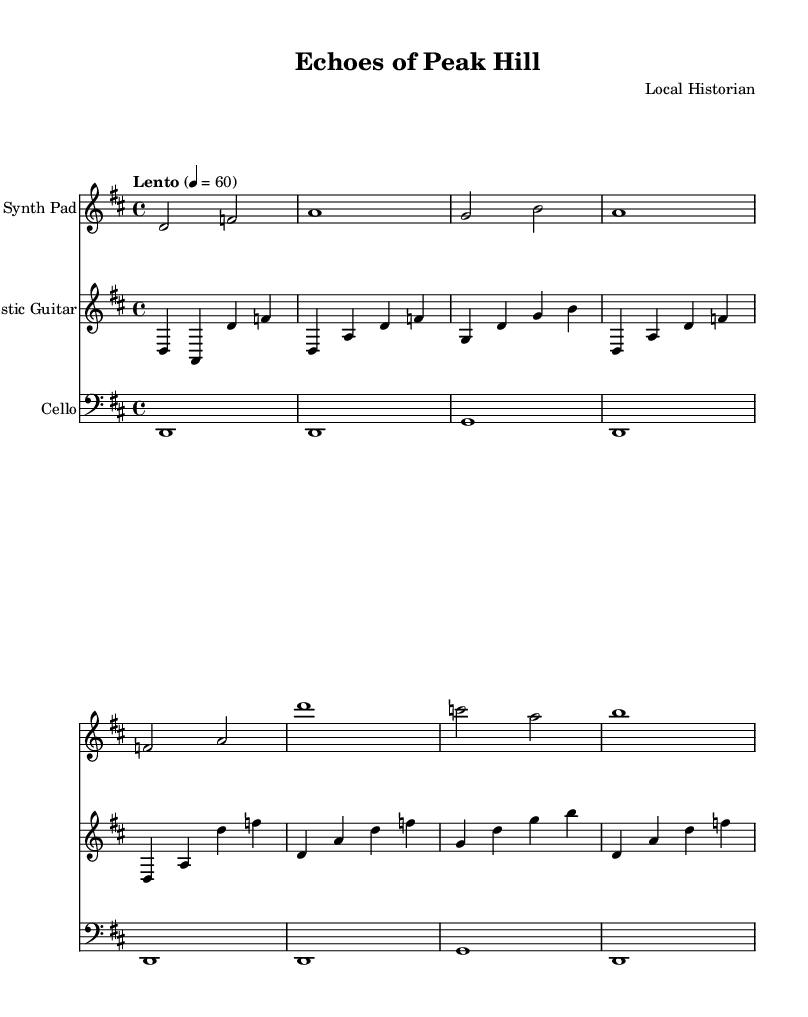What is the key signature of this music? The key signature is D major, which has two sharps: F# and C#. This information can be determined by looking at the key signature indication at the beginning of the score.
Answer: D major What is the time signature of this music? The time signature is 4/4, which means there are four beats in each measure and a quarter note gets one beat. This can be identified by the time signature marking placed at the beginning of the score.
Answer: 4/4 What tempo marking is indicated in this music? The tempo marking is "Lento," which signifies a slow tempo, typically around 60 beats per minute. This marking is found at the start of the score, specifying the intended speed of the piece.
Answer: Lento How many measures are in the synth pad part? The synth pad part contains eight measures, as indicated by the spacing and layout of the notes shown in the score. Each distinct grouping of notes is counted as one measure.
Answer: 8 Which instruments are featured in this composition? The instruments featured in this composition are a Synth Pad, Acoustic Guitar, and Cello. The title for each instrument is displayed at the beginning of each staff, identifying what plays in that part.
Answer: Synth Pad, Acoustic Guitar, Cello What is the function of the cello in this piece? The cello plays sustained notes throughout the piece, providing a harmonic foundation. This can be deduced from the single whole notes in each measure, indicating a drone-like support role.
Answer: Harmonic foundation 